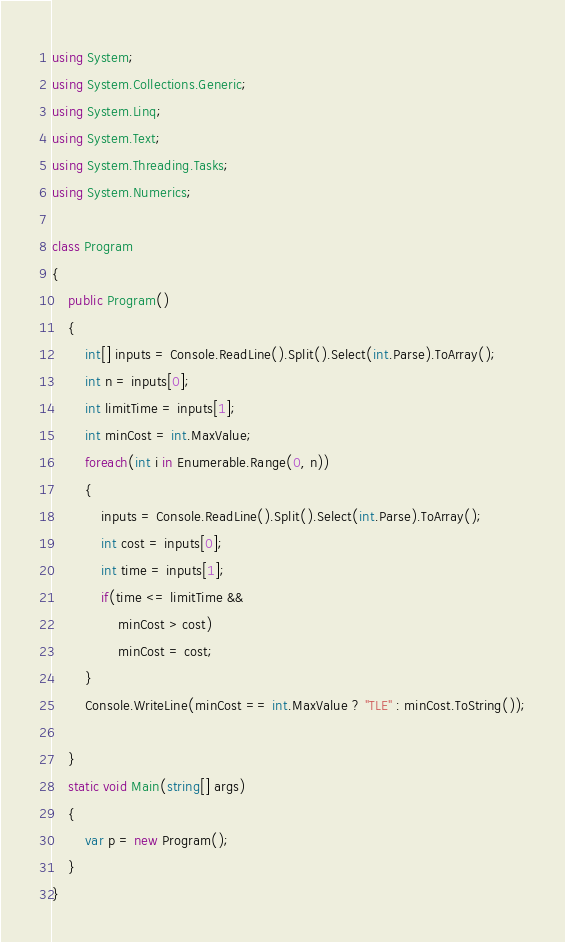<code> <loc_0><loc_0><loc_500><loc_500><_C#_>using System;
using System.Collections.Generic;
using System.Linq;
using System.Text;
using System.Threading.Tasks;
using System.Numerics;

class Program
{
    public Program()
    {
        int[] inputs = Console.ReadLine().Split().Select(int.Parse).ToArray(); 
        int n = inputs[0];
        int limitTime = inputs[1];
        int minCost = int.MaxValue;
        foreach(int i in Enumerable.Range(0, n))
        {
            inputs = Console.ReadLine().Split().Select(int.Parse).ToArray();
            int cost = inputs[0];
            int time = inputs[1];
            if(time <= limitTime && 
                minCost > cost)
                minCost = cost;
        }
        Console.WriteLine(minCost == int.MaxValue ? "TLE" : minCost.ToString());

    }
    static void Main(string[] args)
    {
        var p = new Program();
    }
}
</code> 